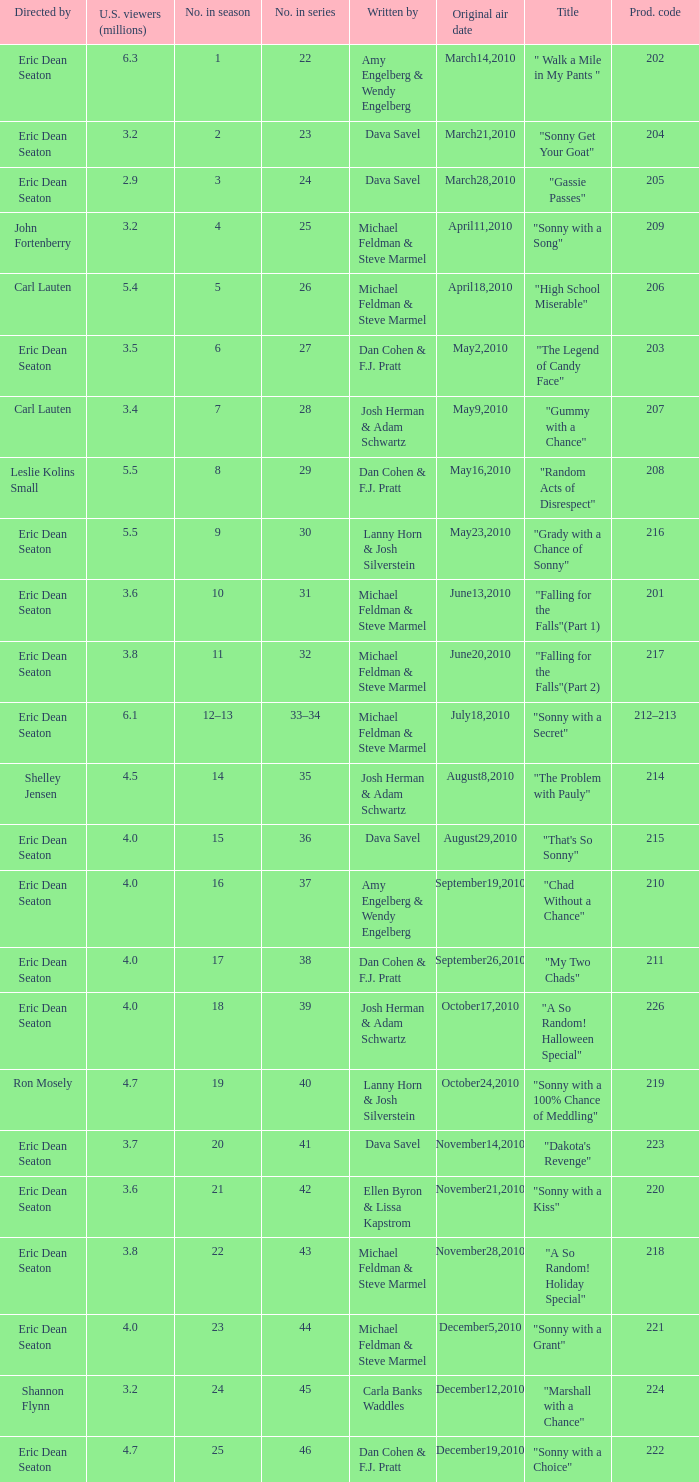How man episodes in the season were titled "that's so sonny"? 1.0. 